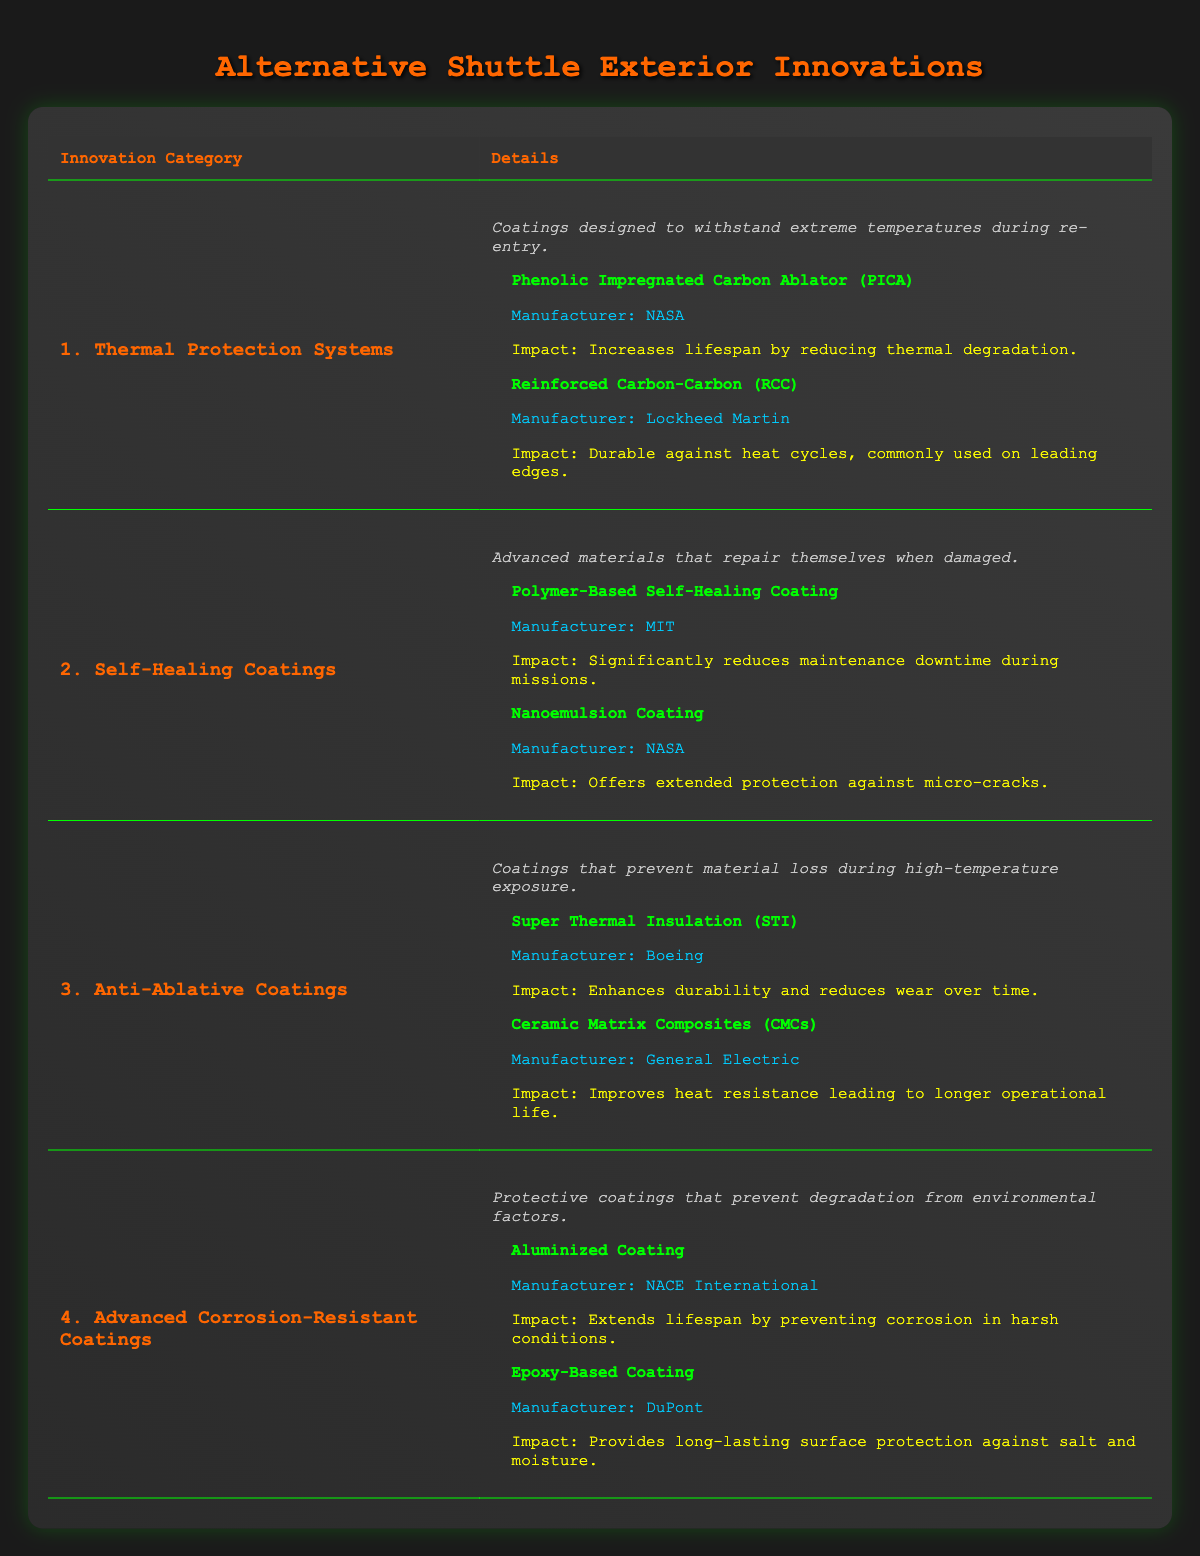What are the examples of Thermal Protection Systems? The table lists two examples under Thermal Protection Systems: Phenolic Impregnated Carbon Ablator (PICA) and Reinforced Carbon-Carbon (RCC).
Answer: PICA and RCC What is the manufacturer of Nanoemulsion Coating? From the table, it shows that Nanoemulsion Coating is manufactured by NASA.
Answer: NASA Which coating significantly reduces maintenance downtime during missions? The Polymer-Based Self-Healing Coating is specifically mentioned in the table as having a significant impact on reducing maintenance downtime during missions.
Answer: Polymer-Based Self-Healing Coating How many examples are there under Advanced Corrosion-Resistant Coatings? The table lists two examples under Advanced Corrosion-Resistant Coatings: Aluminized Coating and Epoxy-Based Coating. Therefore, there are 2 examples.
Answer: 2 Do any of the self-healing coatings come from MIT? Yes, the Polymer-Based Self-Healing Coating is indicated in the table as being manufactured by MIT.
Answer: Yes Which coating type improves heat resistance leading to longer operational life? The table states that Ceramic Matrix Composites (CMCs) improve heat resistance leading to longer operational life.
Answer: Ceramic Matrix Composites (CMCs) What are the longevity impacts of Anti-Ablative Coatings found in the table? The table lists two Anti-Ablative Coatings: Super Thermal Insulation (STI), which enhances durability and reduces wear over time, and Ceramic Matrix Composites (CMCs), which improves heat resistance leading to longer operational life. Hence, both contribute positively to longevity.
Answer: Enhances durability and reduces wear; improves heat resistance Which system has a longevity impact related to reducing thermal degradation? The Phenolic Impregnated Carbon Ablator (PICA) is the system that has a longevity impact by reducing thermal degradation according to the table.
Answer: PICA If we consider the longevity impacts of all the coatings listed, which two systems contribute to protection against extreme environmental factors? From the table, the Advanced Corrosion-Resistant Coatings are noted for preventing degradation from environmental factors, specifically Aluminized Coating and Epoxy-Based Coating. Both are designed for such protection.
Answer: Aluminized Coating and Epoxy-Based Coating 